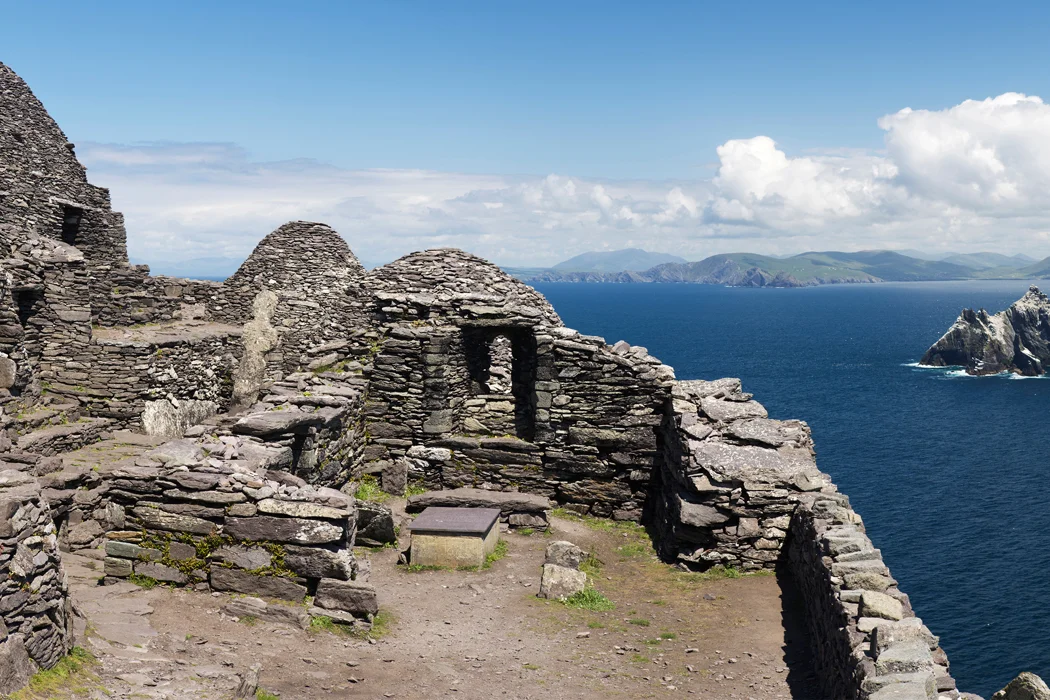What types of wildlife might one encounter around this island? Skellig Michael is not only a historical site but also a haven for various wildlife, particularly seabirds. The island serves as one of Europe's most important breeding sites for seabirds. Visitors can observe species such as puffins, which are prevalent during the summer months, storm petrels, and northern gannets among others. The surrounding waters are also rich with marine life, including dolphins and seals, offering a rich tableau of biodiversity that complements the island's stark historical beauty. 